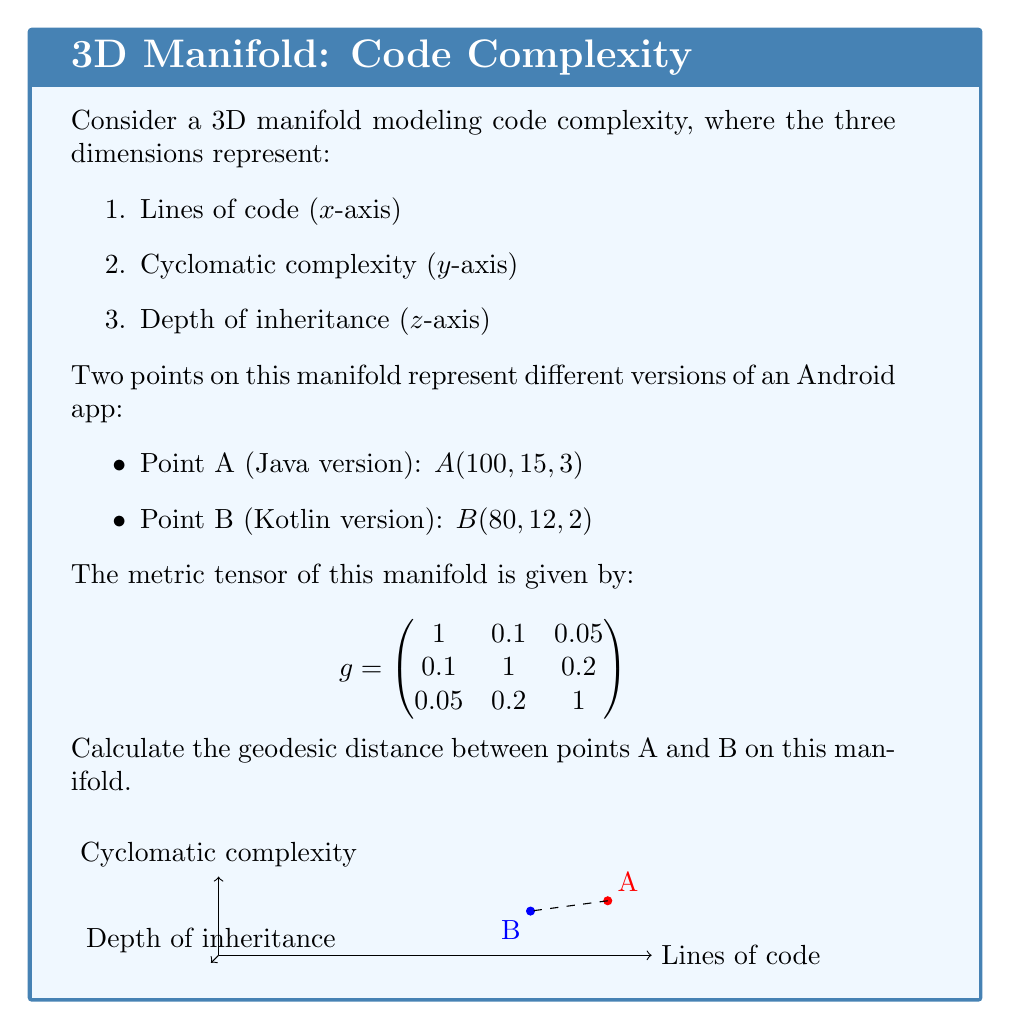Solve this math problem. To calculate the geodesic distance between two points on a 3D manifold, we'll follow these steps:

1. Calculate the difference vector $\Delta x$ between points A and B:
   $\Delta x = B - A = (80-100, 12-15, 2-3) = (-20, -3, -1)$

2. Compute the squared distance using the metric tensor:
   $ds^2 = \Delta x^T g \Delta x$

   $ds^2 = \begin{pmatrix} -20 & -3 & -1 \end{pmatrix} \begin{pmatrix}
   1 & 0.1 & 0.05 \\
   0.1 & 1 & 0.2 \\
   0.05 & 0.2 & 1
   \end{pmatrix} \begin{pmatrix} -20 \\ -3 \\ -1 \end{pmatrix}$

3. Multiply the matrices:
   $ds^2 = \begin{pmatrix} -20 & -3 & -1 \end{pmatrix} \begin{pmatrix} -20 \\ -3.6 \\ -1.55 \end{pmatrix}$

4. Compute the final result:
   $ds^2 = 400 + 10.8 + 1.55 = 412.35$

5. Take the square root to get the geodesic distance:
   $ds = \sqrt{412.35} \approx 20.31$

This geodesic distance represents the "shortest path" between the Java and Kotlin versions of the app in terms of code complexity, taking into account the relationships between the different complexity metrics.
Answer: $20.31$ units 